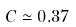Convert formula to latex. <formula><loc_0><loc_0><loc_500><loc_500>C \simeq 0 . 3 7</formula> 